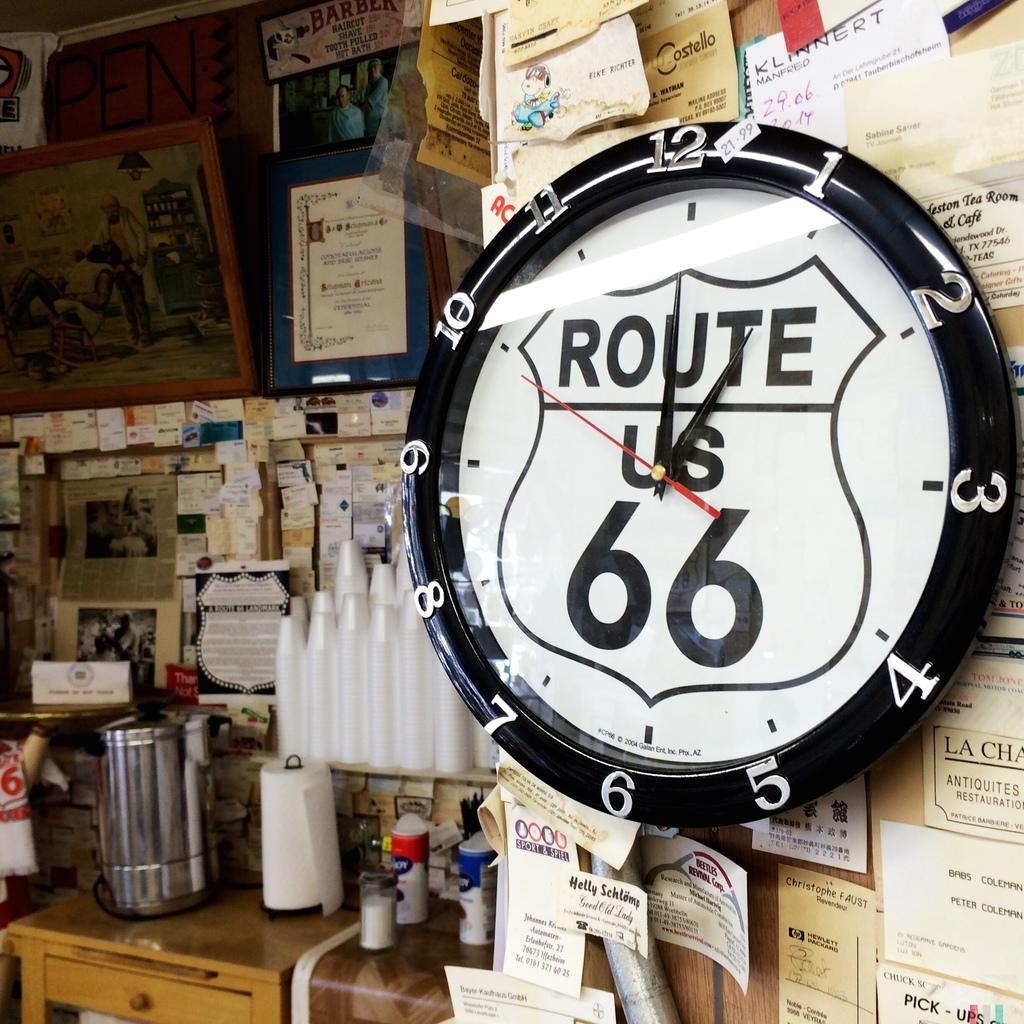<image>
Present a compact description of the photo's key features. the route 66 that is on a clock 